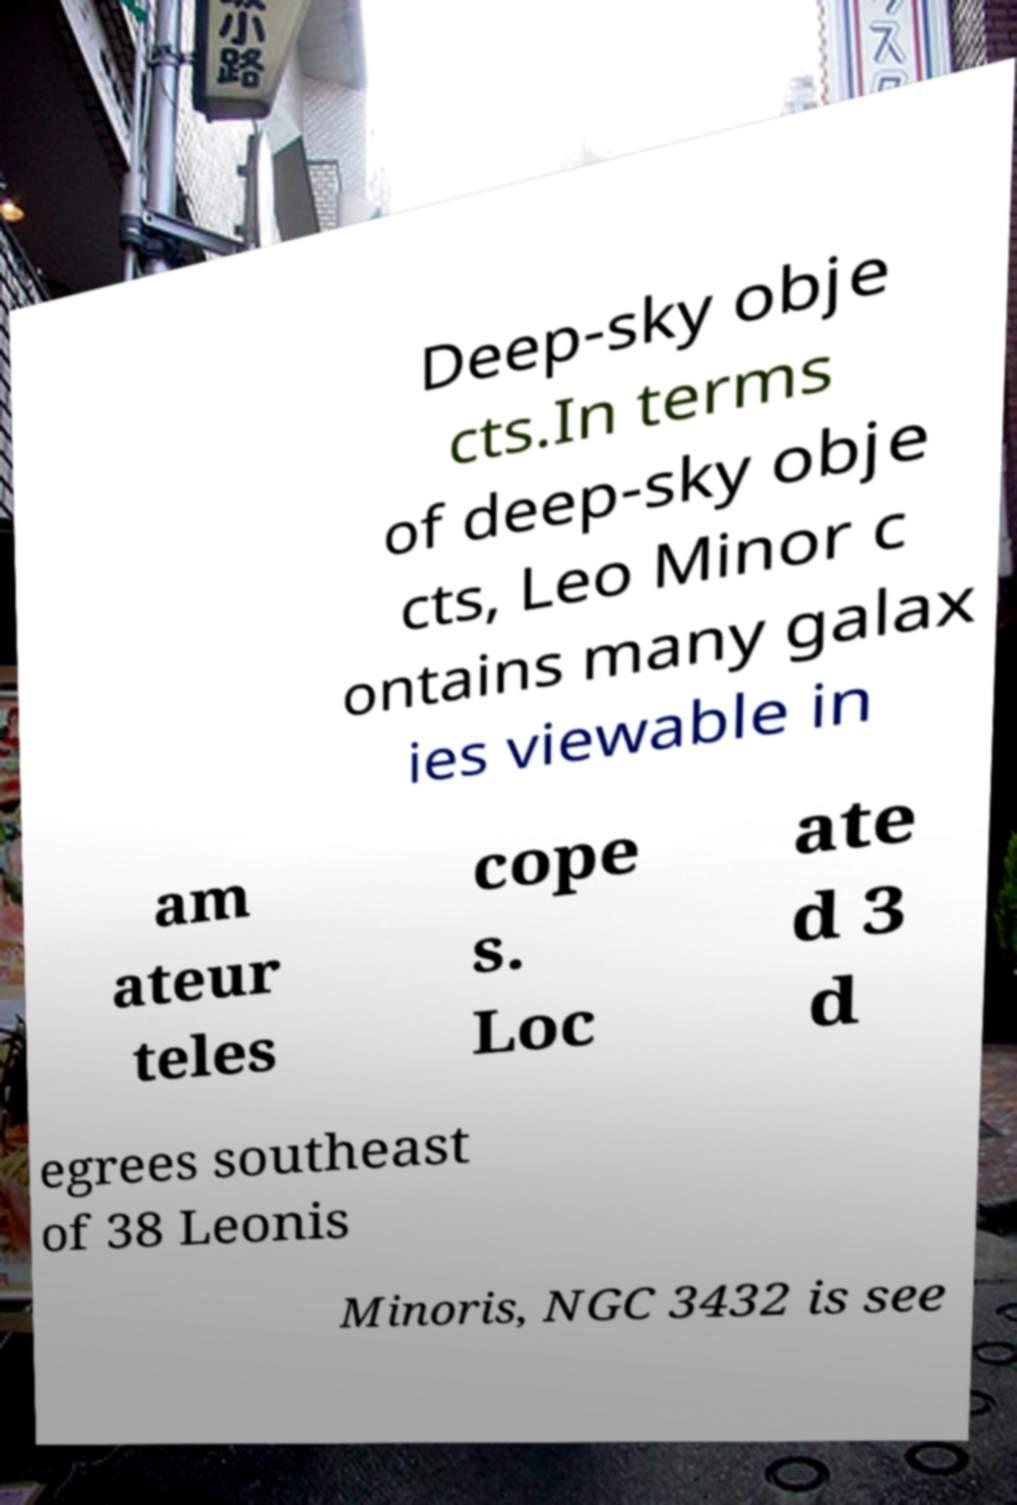There's text embedded in this image that I need extracted. Can you transcribe it verbatim? Deep-sky obje cts.In terms of deep-sky obje cts, Leo Minor c ontains many galax ies viewable in am ateur teles cope s. Loc ate d 3 d egrees southeast of 38 Leonis Minoris, NGC 3432 is see 